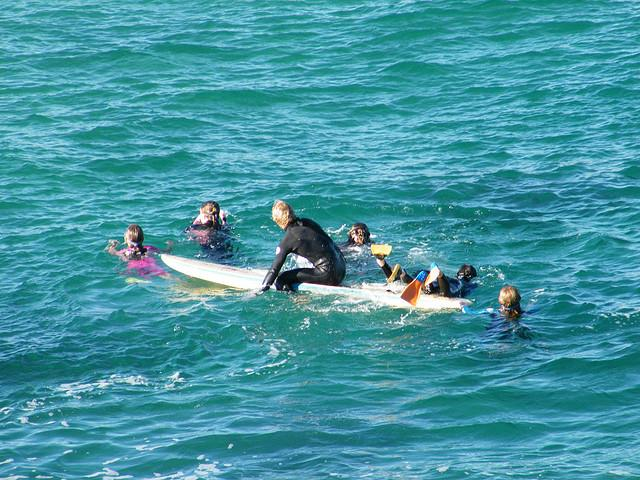What is the orange object on the woman's foot? flipper 